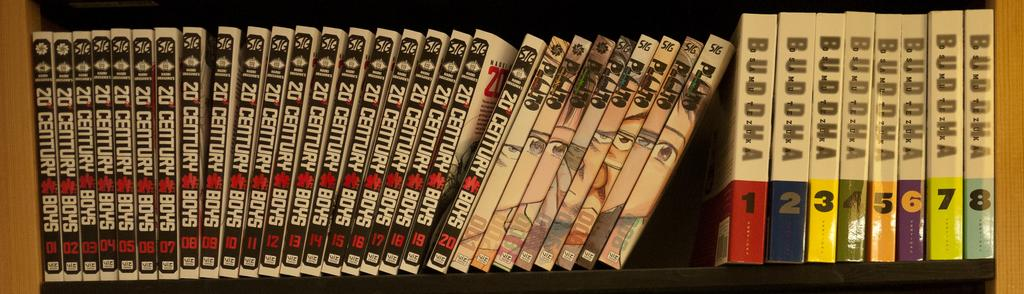<image>
Write a terse but informative summary of the picture. A set of black books with white writing on a shelf are numbered from one through twenty. 